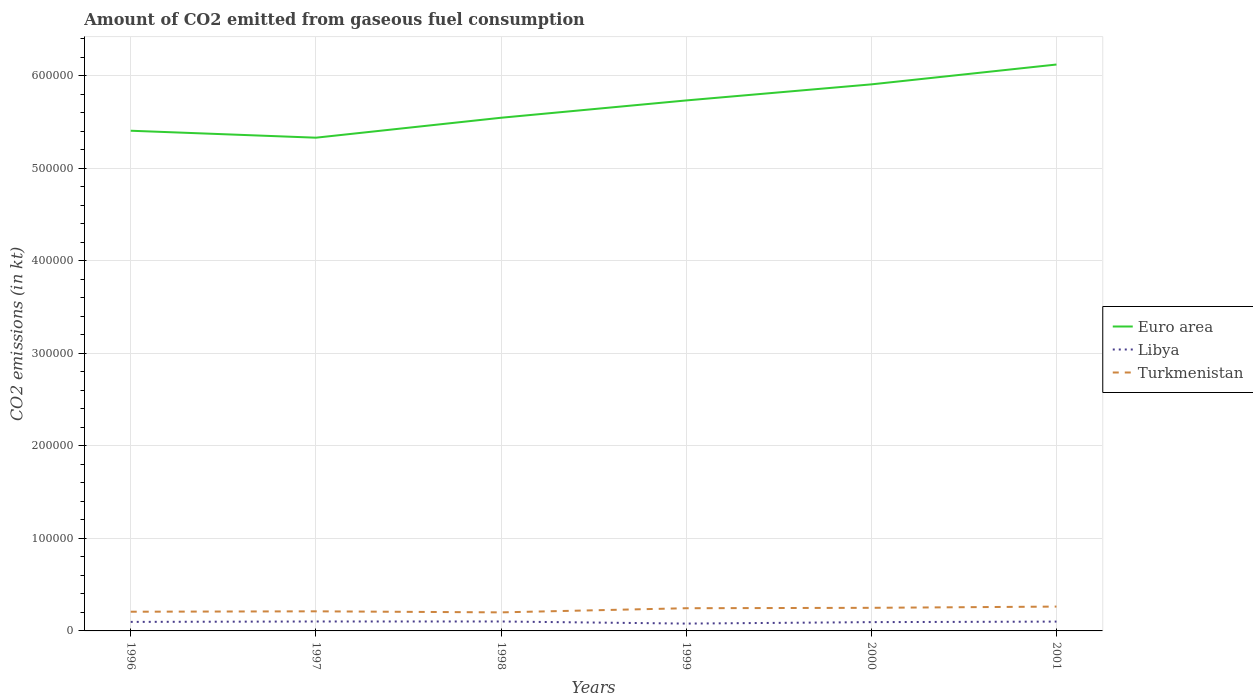Across all years, what is the maximum amount of CO2 emitted in Libya?
Ensure brevity in your answer.  7931.72. What is the total amount of CO2 emitted in Turkmenistan in the graph?
Your response must be concise. -425.37. What is the difference between the highest and the second highest amount of CO2 emitted in Libya?
Your response must be concise. 2266.21. What is the difference between the highest and the lowest amount of CO2 emitted in Libya?
Offer a terse response. 4. What is the difference between two consecutive major ticks on the Y-axis?
Give a very brief answer. 1.00e+05. Where does the legend appear in the graph?
Provide a short and direct response. Center right. What is the title of the graph?
Offer a terse response. Amount of CO2 emitted from gaseous fuel consumption. Does "Qatar" appear as one of the legend labels in the graph?
Your response must be concise. No. What is the label or title of the X-axis?
Your response must be concise. Years. What is the label or title of the Y-axis?
Your response must be concise. CO2 emissions (in kt). What is the CO2 emissions (in kt) in Euro area in 1996?
Your answer should be compact. 5.41e+05. What is the CO2 emissions (in kt) in Libya in 1996?
Provide a succinct answer. 9765.22. What is the CO2 emissions (in kt) in Turkmenistan in 1996?
Give a very brief answer. 2.08e+04. What is the CO2 emissions (in kt) in Euro area in 1997?
Provide a short and direct response. 5.33e+05. What is the CO2 emissions (in kt) in Libya in 1997?
Your answer should be compact. 1.02e+04. What is the CO2 emissions (in kt) in Turkmenistan in 1997?
Offer a terse response. 2.12e+04. What is the CO2 emissions (in kt) in Euro area in 1998?
Offer a very short reply. 5.55e+05. What is the CO2 emissions (in kt) in Libya in 1998?
Provide a short and direct response. 1.02e+04. What is the CO2 emissions (in kt) in Turkmenistan in 1998?
Your answer should be compact. 2.01e+04. What is the CO2 emissions (in kt) in Euro area in 1999?
Keep it short and to the point. 5.73e+05. What is the CO2 emissions (in kt) of Libya in 1999?
Your answer should be compact. 7931.72. What is the CO2 emissions (in kt) of Turkmenistan in 1999?
Give a very brief answer. 2.45e+04. What is the CO2 emissions (in kt) of Euro area in 2000?
Provide a short and direct response. 5.91e+05. What is the CO2 emissions (in kt) in Libya in 2000?
Your answer should be compact. 9504.86. What is the CO2 emissions (in kt) in Turkmenistan in 2000?
Provide a succinct answer. 2.50e+04. What is the CO2 emissions (in kt) in Euro area in 2001?
Your response must be concise. 6.12e+05. What is the CO2 emissions (in kt) of Libya in 2001?
Your response must be concise. 1.01e+04. What is the CO2 emissions (in kt) in Turkmenistan in 2001?
Give a very brief answer. 2.63e+04. Across all years, what is the maximum CO2 emissions (in kt) of Euro area?
Keep it short and to the point. 6.12e+05. Across all years, what is the maximum CO2 emissions (in kt) in Libya?
Offer a terse response. 1.02e+04. Across all years, what is the maximum CO2 emissions (in kt) in Turkmenistan?
Your answer should be very brief. 2.63e+04. Across all years, what is the minimum CO2 emissions (in kt) in Euro area?
Give a very brief answer. 5.33e+05. Across all years, what is the minimum CO2 emissions (in kt) of Libya?
Provide a succinct answer. 7931.72. Across all years, what is the minimum CO2 emissions (in kt) of Turkmenistan?
Your response must be concise. 2.01e+04. What is the total CO2 emissions (in kt) in Euro area in the graph?
Offer a terse response. 3.40e+06. What is the total CO2 emissions (in kt) in Libya in the graph?
Provide a short and direct response. 5.77e+04. What is the total CO2 emissions (in kt) of Turkmenistan in the graph?
Provide a succinct answer. 1.38e+05. What is the difference between the CO2 emissions (in kt) in Euro area in 1996 and that in 1997?
Make the answer very short. 7521.55. What is the difference between the CO2 emissions (in kt) in Libya in 1996 and that in 1997?
Your response must be concise. -432.71. What is the difference between the CO2 emissions (in kt) in Turkmenistan in 1996 and that in 1997?
Your answer should be compact. -425.37. What is the difference between the CO2 emissions (in kt) in Euro area in 1996 and that in 1998?
Your answer should be compact. -1.40e+04. What is the difference between the CO2 emissions (in kt) in Libya in 1996 and that in 1998?
Ensure brevity in your answer.  -432.71. What is the difference between the CO2 emissions (in kt) of Turkmenistan in 1996 and that in 1998?
Your response must be concise. 704.06. What is the difference between the CO2 emissions (in kt) of Euro area in 1996 and that in 1999?
Your response must be concise. -3.27e+04. What is the difference between the CO2 emissions (in kt) in Libya in 1996 and that in 1999?
Offer a very short reply. 1833.5. What is the difference between the CO2 emissions (in kt) of Turkmenistan in 1996 and that in 1999?
Give a very brief answer. -3780.68. What is the difference between the CO2 emissions (in kt) in Euro area in 1996 and that in 2000?
Your answer should be very brief. -5.01e+04. What is the difference between the CO2 emissions (in kt) in Libya in 1996 and that in 2000?
Your answer should be very brief. 260.36. What is the difference between the CO2 emissions (in kt) in Turkmenistan in 1996 and that in 2000?
Ensure brevity in your answer.  -4213.38. What is the difference between the CO2 emissions (in kt) of Euro area in 1996 and that in 2001?
Provide a succinct answer. -7.16e+04. What is the difference between the CO2 emissions (in kt) in Libya in 1996 and that in 2001?
Provide a short and direct response. -319.03. What is the difference between the CO2 emissions (in kt) of Turkmenistan in 1996 and that in 2001?
Provide a short and direct response. -5548.17. What is the difference between the CO2 emissions (in kt) of Euro area in 1997 and that in 1998?
Your response must be concise. -2.16e+04. What is the difference between the CO2 emissions (in kt) of Libya in 1997 and that in 1998?
Ensure brevity in your answer.  0. What is the difference between the CO2 emissions (in kt) of Turkmenistan in 1997 and that in 1998?
Your answer should be compact. 1129.44. What is the difference between the CO2 emissions (in kt) of Euro area in 1997 and that in 1999?
Give a very brief answer. -4.03e+04. What is the difference between the CO2 emissions (in kt) in Libya in 1997 and that in 1999?
Make the answer very short. 2266.21. What is the difference between the CO2 emissions (in kt) of Turkmenistan in 1997 and that in 1999?
Provide a succinct answer. -3355.3. What is the difference between the CO2 emissions (in kt) of Euro area in 1997 and that in 2000?
Keep it short and to the point. -5.76e+04. What is the difference between the CO2 emissions (in kt) in Libya in 1997 and that in 2000?
Keep it short and to the point. 693.06. What is the difference between the CO2 emissions (in kt) of Turkmenistan in 1997 and that in 2000?
Your response must be concise. -3788.01. What is the difference between the CO2 emissions (in kt) in Euro area in 1997 and that in 2001?
Make the answer very short. -7.91e+04. What is the difference between the CO2 emissions (in kt) in Libya in 1997 and that in 2001?
Offer a terse response. 113.68. What is the difference between the CO2 emissions (in kt) in Turkmenistan in 1997 and that in 2001?
Your answer should be very brief. -5122.8. What is the difference between the CO2 emissions (in kt) of Euro area in 1998 and that in 1999?
Keep it short and to the point. -1.87e+04. What is the difference between the CO2 emissions (in kt) in Libya in 1998 and that in 1999?
Give a very brief answer. 2266.21. What is the difference between the CO2 emissions (in kt) in Turkmenistan in 1998 and that in 1999?
Give a very brief answer. -4484.74. What is the difference between the CO2 emissions (in kt) in Euro area in 1998 and that in 2000?
Offer a very short reply. -3.61e+04. What is the difference between the CO2 emissions (in kt) in Libya in 1998 and that in 2000?
Your answer should be compact. 693.06. What is the difference between the CO2 emissions (in kt) of Turkmenistan in 1998 and that in 2000?
Keep it short and to the point. -4917.45. What is the difference between the CO2 emissions (in kt) in Euro area in 1998 and that in 2001?
Ensure brevity in your answer.  -5.75e+04. What is the difference between the CO2 emissions (in kt) of Libya in 1998 and that in 2001?
Make the answer very short. 113.68. What is the difference between the CO2 emissions (in kt) of Turkmenistan in 1998 and that in 2001?
Give a very brief answer. -6252.23. What is the difference between the CO2 emissions (in kt) of Euro area in 1999 and that in 2000?
Offer a terse response. -1.74e+04. What is the difference between the CO2 emissions (in kt) in Libya in 1999 and that in 2000?
Your response must be concise. -1573.14. What is the difference between the CO2 emissions (in kt) in Turkmenistan in 1999 and that in 2000?
Your response must be concise. -432.71. What is the difference between the CO2 emissions (in kt) in Euro area in 1999 and that in 2001?
Your response must be concise. -3.88e+04. What is the difference between the CO2 emissions (in kt) in Libya in 1999 and that in 2001?
Keep it short and to the point. -2152.53. What is the difference between the CO2 emissions (in kt) in Turkmenistan in 1999 and that in 2001?
Offer a very short reply. -1767.49. What is the difference between the CO2 emissions (in kt) of Euro area in 2000 and that in 2001?
Provide a succinct answer. -2.14e+04. What is the difference between the CO2 emissions (in kt) of Libya in 2000 and that in 2001?
Offer a terse response. -579.39. What is the difference between the CO2 emissions (in kt) of Turkmenistan in 2000 and that in 2001?
Make the answer very short. -1334.79. What is the difference between the CO2 emissions (in kt) of Euro area in 1996 and the CO2 emissions (in kt) of Libya in 1997?
Ensure brevity in your answer.  5.30e+05. What is the difference between the CO2 emissions (in kt) in Euro area in 1996 and the CO2 emissions (in kt) in Turkmenistan in 1997?
Your response must be concise. 5.19e+05. What is the difference between the CO2 emissions (in kt) of Libya in 1996 and the CO2 emissions (in kt) of Turkmenistan in 1997?
Offer a very short reply. -1.14e+04. What is the difference between the CO2 emissions (in kt) of Euro area in 1996 and the CO2 emissions (in kt) of Libya in 1998?
Keep it short and to the point. 5.30e+05. What is the difference between the CO2 emissions (in kt) of Euro area in 1996 and the CO2 emissions (in kt) of Turkmenistan in 1998?
Your response must be concise. 5.21e+05. What is the difference between the CO2 emissions (in kt) of Libya in 1996 and the CO2 emissions (in kt) of Turkmenistan in 1998?
Give a very brief answer. -1.03e+04. What is the difference between the CO2 emissions (in kt) in Euro area in 1996 and the CO2 emissions (in kt) in Libya in 1999?
Your answer should be very brief. 5.33e+05. What is the difference between the CO2 emissions (in kt) in Euro area in 1996 and the CO2 emissions (in kt) in Turkmenistan in 1999?
Your answer should be very brief. 5.16e+05. What is the difference between the CO2 emissions (in kt) in Libya in 1996 and the CO2 emissions (in kt) in Turkmenistan in 1999?
Your answer should be very brief. -1.48e+04. What is the difference between the CO2 emissions (in kt) in Euro area in 1996 and the CO2 emissions (in kt) in Libya in 2000?
Provide a succinct answer. 5.31e+05. What is the difference between the CO2 emissions (in kt) of Euro area in 1996 and the CO2 emissions (in kt) of Turkmenistan in 2000?
Provide a short and direct response. 5.16e+05. What is the difference between the CO2 emissions (in kt) of Libya in 1996 and the CO2 emissions (in kt) of Turkmenistan in 2000?
Ensure brevity in your answer.  -1.52e+04. What is the difference between the CO2 emissions (in kt) in Euro area in 1996 and the CO2 emissions (in kt) in Libya in 2001?
Keep it short and to the point. 5.31e+05. What is the difference between the CO2 emissions (in kt) in Euro area in 1996 and the CO2 emissions (in kt) in Turkmenistan in 2001?
Keep it short and to the point. 5.14e+05. What is the difference between the CO2 emissions (in kt) of Libya in 1996 and the CO2 emissions (in kt) of Turkmenistan in 2001?
Provide a succinct answer. -1.65e+04. What is the difference between the CO2 emissions (in kt) of Euro area in 1997 and the CO2 emissions (in kt) of Libya in 1998?
Provide a succinct answer. 5.23e+05. What is the difference between the CO2 emissions (in kt) of Euro area in 1997 and the CO2 emissions (in kt) of Turkmenistan in 1998?
Offer a terse response. 5.13e+05. What is the difference between the CO2 emissions (in kt) of Libya in 1997 and the CO2 emissions (in kt) of Turkmenistan in 1998?
Provide a succinct answer. -9853.23. What is the difference between the CO2 emissions (in kt) in Euro area in 1997 and the CO2 emissions (in kt) in Libya in 1999?
Give a very brief answer. 5.25e+05. What is the difference between the CO2 emissions (in kt) of Euro area in 1997 and the CO2 emissions (in kt) of Turkmenistan in 1999?
Offer a very short reply. 5.09e+05. What is the difference between the CO2 emissions (in kt) of Libya in 1997 and the CO2 emissions (in kt) of Turkmenistan in 1999?
Keep it short and to the point. -1.43e+04. What is the difference between the CO2 emissions (in kt) in Euro area in 1997 and the CO2 emissions (in kt) in Libya in 2000?
Offer a very short reply. 5.24e+05. What is the difference between the CO2 emissions (in kt) of Euro area in 1997 and the CO2 emissions (in kt) of Turkmenistan in 2000?
Your response must be concise. 5.08e+05. What is the difference between the CO2 emissions (in kt) in Libya in 1997 and the CO2 emissions (in kt) in Turkmenistan in 2000?
Offer a very short reply. -1.48e+04. What is the difference between the CO2 emissions (in kt) of Euro area in 1997 and the CO2 emissions (in kt) of Libya in 2001?
Offer a very short reply. 5.23e+05. What is the difference between the CO2 emissions (in kt) of Euro area in 1997 and the CO2 emissions (in kt) of Turkmenistan in 2001?
Provide a succinct answer. 5.07e+05. What is the difference between the CO2 emissions (in kt) of Libya in 1997 and the CO2 emissions (in kt) of Turkmenistan in 2001?
Your response must be concise. -1.61e+04. What is the difference between the CO2 emissions (in kt) of Euro area in 1998 and the CO2 emissions (in kt) of Libya in 1999?
Give a very brief answer. 5.47e+05. What is the difference between the CO2 emissions (in kt) in Euro area in 1998 and the CO2 emissions (in kt) in Turkmenistan in 1999?
Provide a succinct answer. 5.30e+05. What is the difference between the CO2 emissions (in kt) of Libya in 1998 and the CO2 emissions (in kt) of Turkmenistan in 1999?
Offer a terse response. -1.43e+04. What is the difference between the CO2 emissions (in kt) in Euro area in 1998 and the CO2 emissions (in kt) in Libya in 2000?
Your answer should be very brief. 5.45e+05. What is the difference between the CO2 emissions (in kt) in Euro area in 1998 and the CO2 emissions (in kt) in Turkmenistan in 2000?
Provide a short and direct response. 5.30e+05. What is the difference between the CO2 emissions (in kt) of Libya in 1998 and the CO2 emissions (in kt) of Turkmenistan in 2000?
Keep it short and to the point. -1.48e+04. What is the difference between the CO2 emissions (in kt) of Euro area in 1998 and the CO2 emissions (in kt) of Libya in 2001?
Provide a short and direct response. 5.45e+05. What is the difference between the CO2 emissions (in kt) in Euro area in 1998 and the CO2 emissions (in kt) in Turkmenistan in 2001?
Make the answer very short. 5.28e+05. What is the difference between the CO2 emissions (in kt) in Libya in 1998 and the CO2 emissions (in kt) in Turkmenistan in 2001?
Your response must be concise. -1.61e+04. What is the difference between the CO2 emissions (in kt) of Euro area in 1999 and the CO2 emissions (in kt) of Libya in 2000?
Your answer should be very brief. 5.64e+05. What is the difference between the CO2 emissions (in kt) of Euro area in 1999 and the CO2 emissions (in kt) of Turkmenistan in 2000?
Offer a terse response. 5.48e+05. What is the difference between the CO2 emissions (in kt) in Libya in 1999 and the CO2 emissions (in kt) in Turkmenistan in 2000?
Your response must be concise. -1.70e+04. What is the difference between the CO2 emissions (in kt) of Euro area in 1999 and the CO2 emissions (in kt) of Libya in 2001?
Offer a terse response. 5.63e+05. What is the difference between the CO2 emissions (in kt) in Euro area in 1999 and the CO2 emissions (in kt) in Turkmenistan in 2001?
Keep it short and to the point. 5.47e+05. What is the difference between the CO2 emissions (in kt) of Libya in 1999 and the CO2 emissions (in kt) of Turkmenistan in 2001?
Your answer should be very brief. -1.84e+04. What is the difference between the CO2 emissions (in kt) of Euro area in 2000 and the CO2 emissions (in kt) of Libya in 2001?
Offer a terse response. 5.81e+05. What is the difference between the CO2 emissions (in kt) of Euro area in 2000 and the CO2 emissions (in kt) of Turkmenistan in 2001?
Your answer should be compact. 5.64e+05. What is the difference between the CO2 emissions (in kt) of Libya in 2000 and the CO2 emissions (in kt) of Turkmenistan in 2001?
Offer a terse response. -1.68e+04. What is the average CO2 emissions (in kt) in Euro area per year?
Provide a short and direct response. 5.67e+05. What is the average CO2 emissions (in kt) in Libya per year?
Offer a very short reply. 9613.65. What is the average CO2 emissions (in kt) in Turkmenistan per year?
Provide a succinct answer. 2.30e+04. In the year 1996, what is the difference between the CO2 emissions (in kt) in Euro area and CO2 emissions (in kt) in Libya?
Give a very brief answer. 5.31e+05. In the year 1996, what is the difference between the CO2 emissions (in kt) of Euro area and CO2 emissions (in kt) of Turkmenistan?
Keep it short and to the point. 5.20e+05. In the year 1996, what is the difference between the CO2 emissions (in kt) in Libya and CO2 emissions (in kt) in Turkmenistan?
Keep it short and to the point. -1.10e+04. In the year 1997, what is the difference between the CO2 emissions (in kt) in Euro area and CO2 emissions (in kt) in Libya?
Provide a succinct answer. 5.23e+05. In the year 1997, what is the difference between the CO2 emissions (in kt) in Euro area and CO2 emissions (in kt) in Turkmenistan?
Ensure brevity in your answer.  5.12e+05. In the year 1997, what is the difference between the CO2 emissions (in kt) in Libya and CO2 emissions (in kt) in Turkmenistan?
Offer a very short reply. -1.10e+04. In the year 1998, what is the difference between the CO2 emissions (in kt) of Euro area and CO2 emissions (in kt) of Libya?
Ensure brevity in your answer.  5.44e+05. In the year 1998, what is the difference between the CO2 emissions (in kt) of Euro area and CO2 emissions (in kt) of Turkmenistan?
Offer a terse response. 5.35e+05. In the year 1998, what is the difference between the CO2 emissions (in kt) of Libya and CO2 emissions (in kt) of Turkmenistan?
Make the answer very short. -9853.23. In the year 1999, what is the difference between the CO2 emissions (in kt) in Euro area and CO2 emissions (in kt) in Libya?
Your answer should be compact. 5.65e+05. In the year 1999, what is the difference between the CO2 emissions (in kt) of Euro area and CO2 emissions (in kt) of Turkmenistan?
Make the answer very short. 5.49e+05. In the year 1999, what is the difference between the CO2 emissions (in kt) in Libya and CO2 emissions (in kt) in Turkmenistan?
Make the answer very short. -1.66e+04. In the year 2000, what is the difference between the CO2 emissions (in kt) in Euro area and CO2 emissions (in kt) in Libya?
Ensure brevity in your answer.  5.81e+05. In the year 2000, what is the difference between the CO2 emissions (in kt) in Euro area and CO2 emissions (in kt) in Turkmenistan?
Offer a terse response. 5.66e+05. In the year 2000, what is the difference between the CO2 emissions (in kt) in Libya and CO2 emissions (in kt) in Turkmenistan?
Provide a short and direct response. -1.55e+04. In the year 2001, what is the difference between the CO2 emissions (in kt) of Euro area and CO2 emissions (in kt) of Libya?
Your answer should be very brief. 6.02e+05. In the year 2001, what is the difference between the CO2 emissions (in kt) of Euro area and CO2 emissions (in kt) of Turkmenistan?
Offer a terse response. 5.86e+05. In the year 2001, what is the difference between the CO2 emissions (in kt) of Libya and CO2 emissions (in kt) of Turkmenistan?
Your answer should be very brief. -1.62e+04. What is the ratio of the CO2 emissions (in kt) of Euro area in 1996 to that in 1997?
Offer a terse response. 1.01. What is the ratio of the CO2 emissions (in kt) in Libya in 1996 to that in 1997?
Offer a very short reply. 0.96. What is the ratio of the CO2 emissions (in kt) in Turkmenistan in 1996 to that in 1997?
Make the answer very short. 0.98. What is the ratio of the CO2 emissions (in kt) of Euro area in 1996 to that in 1998?
Make the answer very short. 0.97. What is the ratio of the CO2 emissions (in kt) of Libya in 1996 to that in 1998?
Ensure brevity in your answer.  0.96. What is the ratio of the CO2 emissions (in kt) of Turkmenistan in 1996 to that in 1998?
Offer a terse response. 1.04. What is the ratio of the CO2 emissions (in kt) in Euro area in 1996 to that in 1999?
Your response must be concise. 0.94. What is the ratio of the CO2 emissions (in kt) in Libya in 1996 to that in 1999?
Your response must be concise. 1.23. What is the ratio of the CO2 emissions (in kt) in Turkmenistan in 1996 to that in 1999?
Keep it short and to the point. 0.85. What is the ratio of the CO2 emissions (in kt) of Euro area in 1996 to that in 2000?
Your answer should be very brief. 0.92. What is the ratio of the CO2 emissions (in kt) in Libya in 1996 to that in 2000?
Offer a very short reply. 1.03. What is the ratio of the CO2 emissions (in kt) of Turkmenistan in 1996 to that in 2000?
Your response must be concise. 0.83. What is the ratio of the CO2 emissions (in kt) in Euro area in 1996 to that in 2001?
Your answer should be very brief. 0.88. What is the ratio of the CO2 emissions (in kt) of Libya in 1996 to that in 2001?
Ensure brevity in your answer.  0.97. What is the ratio of the CO2 emissions (in kt) of Turkmenistan in 1996 to that in 2001?
Keep it short and to the point. 0.79. What is the ratio of the CO2 emissions (in kt) of Euro area in 1997 to that in 1998?
Ensure brevity in your answer.  0.96. What is the ratio of the CO2 emissions (in kt) in Turkmenistan in 1997 to that in 1998?
Offer a very short reply. 1.06. What is the ratio of the CO2 emissions (in kt) of Euro area in 1997 to that in 1999?
Make the answer very short. 0.93. What is the ratio of the CO2 emissions (in kt) of Libya in 1997 to that in 1999?
Your answer should be compact. 1.29. What is the ratio of the CO2 emissions (in kt) in Turkmenistan in 1997 to that in 1999?
Offer a terse response. 0.86. What is the ratio of the CO2 emissions (in kt) in Euro area in 1997 to that in 2000?
Give a very brief answer. 0.9. What is the ratio of the CO2 emissions (in kt) in Libya in 1997 to that in 2000?
Your answer should be compact. 1.07. What is the ratio of the CO2 emissions (in kt) in Turkmenistan in 1997 to that in 2000?
Make the answer very short. 0.85. What is the ratio of the CO2 emissions (in kt) in Euro area in 1997 to that in 2001?
Ensure brevity in your answer.  0.87. What is the ratio of the CO2 emissions (in kt) in Libya in 1997 to that in 2001?
Ensure brevity in your answer.  1.01. What is the ratio of the CO2 emissions (in kt) in Turkmenistan in 1997 to that in 2001?
Provide a short and direct response. 0.81. What is the ratio of the CO2 emissions (in kt) of Euro area in 1998 to that in 1999?
Your answer should be very brief. 0.97. What is the ratio of the CO2 emissions (in kt) of Turkmenistan in 1998 to that in 1999?
Offer a terse response. 0.82. What is the ratio of the CO2 emissions (in kt) in Euro area in 1998 to that in 2000?
Your answer should be compact. 0.94. What is the ratio of the CO2 emissions (in kt) of Libya in 1998 to that in 2000?
Give a very brief answer. 1.07. What is the ratio of the CO2 emissions (in kt) of Turkmenistan in 1998 to that in 2000?
Keep it short and to the point. 0.8. What is the ratio of the CO2 emissions (in kt) of Euro area in 1998 to that in 2001?
Offer a very short reply. 0.91. What is the ratio of the CO2 emissions (in kt) of Libya in 1998 to that in 2001?
Make the answer very short. 1.01. What is the ratio of the CO2 emissions (in kt) of Turkmenistan in 1998 to that in 2001?
Keep it short and to the point. 0.76. What is the ratio of the CO2 emissions (in kt) in Euro area in 1999 to that in 2000?
Your answer should be compact. 0.97. What is the ratio of the CO2 emissions (in kt) in Libya in 1999 to that in 2000?
Ensure brevity in your answer.  0.83. What is the ratio of the CO2 emissions (in kt) of Turkmenistan in 1999 to that in 2000?
Give a very brief answer. 0.98. What is the ratio of the CO2 emissions (in kt) in Euro area in 1999 to that in 2001?
Your response must be concise. 0.94. What is the ratio of the CO2 emissions (in kt) in Libya in 1999 to that in 2001?
Ensure brevity in your answer.  0.79. What is the ratio of the CO2 emissions (in kt) of Turkmenistan in 1999 to that in 2001?
Offer a very short reply. 0.93. What is the ratio of the CO2 emissions (in kt) in Euro area in 2000 to that in 2001?
Your answer should be compact. 0.96. What is the ratio of the CO2 emissions (in kt) in Libya in 2000 to that in 2001?
Offer a terse response. 0.94. What is the ratio of the CO2 emissions (in kt) of Turkmenistan in 2000 to that in 2001?
Your answer should be very brief. 0.95. What is the difference between the highest and the second highest CO2 emissions (in kt) of Euro area?
Ensure brevity in your answer.  2.14e+04. What is the difference between the highest and the second highest CO2 emissions (in kt) in Libya?
Your answer should be very brief. 0. What is the difference between the highest and the second highest CO2 emissions (in kt) of Turkmenistan?
Ensure brevity in your answer.  1334.79. What is the difference between the highest and the lowest CO2 emissions (in kt) in Euro area?
Ensure brevity in your answer.  7.91e+04. What is the difference between the highest and the lowest CO2 emissions (in kt) of Libya?
Ensure brevity in your answer.  2266.21. What is the difference between the highest and the lowest CO2 emissions (in kt) in Turkmenistan?
Give a very brief answer. 6252.23. 